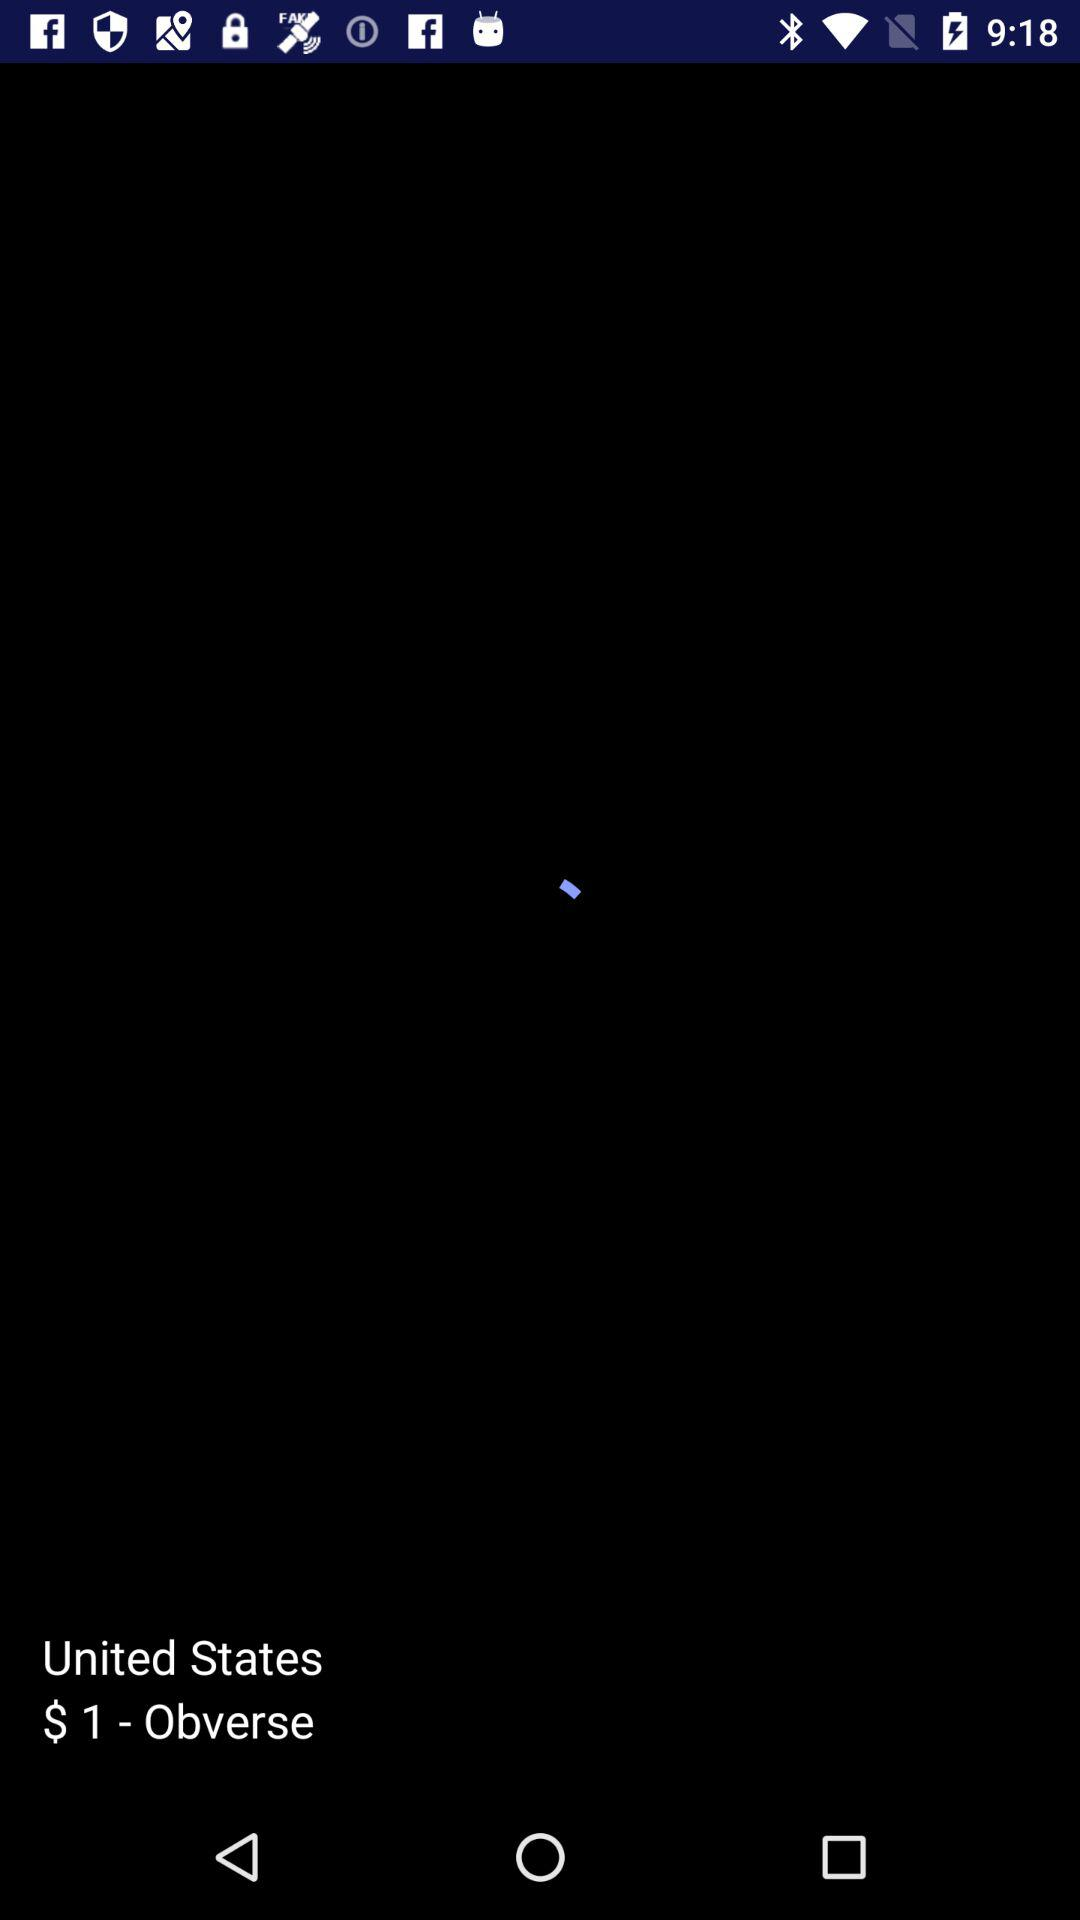What is the name of the application?
When the provided information is insufficient, respond with <no answer>. <no answer> 